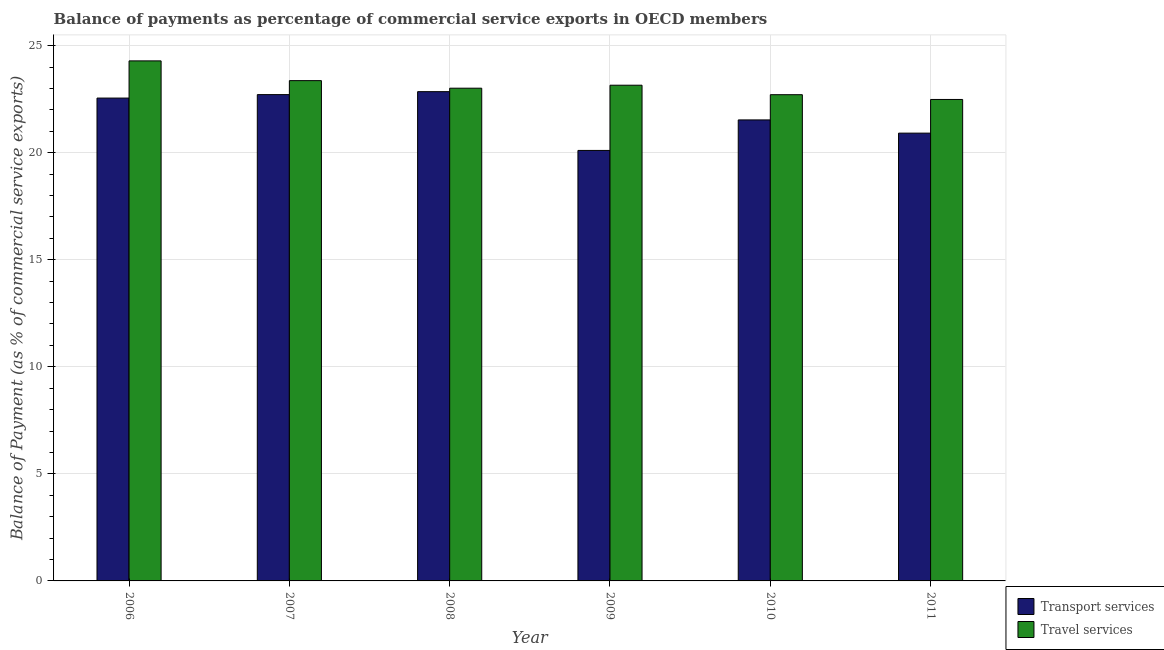How many groups of bars are there?
Offer a terse response. 6. Are the number of bars per tick equal to the number of legend labels?
Provide a succinct answer. Yes. How many bars are there on the 4th tick from the right?
Provide a short and direct response. 2. What is the balance of payments of transport services in 2007?
Give a very brief answer. 22.71. Across all years, what is the maximum balance of payments of travel services?
Make the answer very short. 24.29. Across all years, what is the minimum balance of payments of transport services?
Your answer should be very brief. 20.1. In which year was the balance of payments of transport services minimum?
Offer a terse response. 2009. What is the total balance of payments of travel services in the graph?
Provide a short and direct response. 139. What is the difference between the balance of payments of transport services in 2010 and that in 2011?
Keep it short and to the point. 0.62. What is the difference between the balance of payments of transport services in 2008 and the balance of payments of travel services in 2009?
Keep it short and to the point. 2.75. What is the average balance of payments of transport services per year?
Your response must be concise. 21.78. In the year 2011, what is the difference between the balance of payments of travel services and balance of payments of transport services?
Ensure brevity in your answer.  0. What is the ratio of the balance of payments of travel services in 2008 to that in 2010?
Make the answer very short. 1.01. Is the balance of payments of travel services in 2008 less than that in 2011?
Offer a very short reply. No. What is the difference between the highest and the second highest balance of payments of transport services?
Offer a very short reply. 0.14. What is the difference between the highest and the lowest balance of payments of transport services?
Provide a short and direct response. 2.75. What does the 1st bar from the left in 2010 represents?
Your response must be concise. Transport services. What does the 1st bar from the right in 2010 represents?
Your answer should be very brief. Travel services. How many bars are there?
Offer a very short reply. 12. Are all the bars in the graph horizontal?
Your answer should be very brief. No. How many years are there in the graph?
Your answer should be compact. 6. What is the difference between two consecutive major ticks on the Y-axis?
Your answer should be compact. 5. Where does the legend appear in the graph?
Your answer should be very brief. Bottom right. How are the legend labels stacked?
Your response must be concise. Vertical. What is the title of the graph?
Offer a terse response. Balance of payments as percentage of commercial service exports in OECD members. Does "Lower secondary rate" appear as one of the legend labels in the graph?
Provide a succinct answer. No. What is the label or title of the X-axis?
Your answer should be compact. Year. What is the label or title of the Y-axis?
Your answer should be compact. Balance of Payment (as % of commercial service exports). What is the Balance of Payment (as % of commercial service exports) of Transport services in 2006?
Provide a succinct answer. 22.55. What is the Balance of Payment (as % of commercial service exports) of Travel services in 2006?
Ensure brevity in your answer.  24.29. What is the Balance of Payment (as % of commercial service exports) in Transport services in 2007?
Keep it short and to the point. 22.71. What is the Balance of Payment (as % of commercial service exports) in Travel services in 2007?
Ensure brevity in your answer.  23.36. What is the Balance of Payment (as % of commercial service exports) in Transport services in 2008?
Ensure brevity in your answer.  22.85. What is the Balance of Payment (as % of commercial service exports) in Travel services in 2008?
Give a very brief answer. 23.01. What is the Balance of Payment (as % of commercial service exports) of Transport services in 2009?
Keep it short and to the point. 20.1. What is the Balance of Payment (as % of commercial service exports) in Travel services in 2009?
Offer a very short reply. 23.15. What is the Balance of Payment (as % of commercial service exports) of Transport services in 2010?
Give a very brief answer. 21.53. What is the Balance of Payment (as % of commercial service exports) in Travel services in 2010?
Ensure brevity in your answer.  22.71. What is the Balance of Payment (as % of commercial service exports) of Transport services in 2011?
Your response must be concise. 20.91. What is the Balance of Payment (as % of commercial service exports) of Travel services in 2011?
Ensure brevity in your answer.  22.48. Across all years, what is the maximum Balance of Payment (as % of commercial service exports) in Transport services?
Keep it short and to the point. 22.85. Across all years, what is the maximum Balance of Payment (as % of commercial service exports) in Travel services?
Give a very brief answer. 24.29. Across all years, what is the minimum Balance of Payment (as % of commercial service exports) in Transport services?
Your response must be concise. 20.1. Across all years, what is the minimum Balance of Payment (as % of commercial service exports) in Travel services?
Offer a terse response. 22.48. What is the total Balance of Payment (as % of commercial service exports) in Transport services in the graph?
Offer a terse response. 130.66. What is the total Balance of Payment (as % of commercial service exports) of Travel services in the graph?
Keep it short and to the point. 139. What is the difference between the Balance of Payment (as % of commercial service exports) of Transport services in 2006 and that in 2007?
Give a very brief answer. -0.16. What is the difference between the Balance of Payment (as % of commercial service exports) of Travel services in 2006 and that in 2007?
Make the answer very short. 0.92. What is the difference between the Balance of Payment (as % of commercial service exports) in Transport services in 2006 and that in 2008?
Offer a very short reply. -0.3. What is the difference between the Balance of Payment (as % of commercial service exports) in Travel services in 2006 and that in 2008?
Your response must be concise. 1.28. What is the difference between the Balance of Payment (as % of commercial service exports) of Transport services in 2006 and that in 2009?
Provide a short and direct response. 2.45. What is the difference between the Balance of Payment (as % of commercial service exports) in Travel services in 2006 and that in 2009?
Provide a succinct answer. 1.14. What is the difference between the Balance of Payment (as % of commercial service exports) of Transport services in 2006 and that in 2010?
Make the answer very short. 1.02. What is the difference between the Balance of Payment (as % of commercial service exports) of Travel services in 2006 and that in 2010?
Ensure brevity in your answer.  1.58. What is the difference between the Balance of Payment (as % of commercial service exports) of Transport services in 2006 and that in 2011?
Offer a very short reply. 1.64. What is the difference between the Balance of Payment (as % of commercial service exports) in Travel services in 2006 and that in 2011?
Provide a short and direct response. 1.8. What is the difference between the Balance of Payment (as % of commercial service exports) in Transport services in 2007 and that in 2008?
Your answer should be very brief. -0.14. What is the difference between the Balance of Payment (as % of commercial service exports) in Travel services in 2007 and that in 2008?
Ensure brevity in your answer.  0.35. What is the difference between the Balance of Payment (as % of commercial service exports) of Transport services in 2007 and that in 2009?
Keep it short and to the point. 2.61. What is the difference between the Balance of Payment (as % of commercial service exports) in Travel services in 2007 and that in 2009?
Offer a terse response. 0.21. What is the difference between the Balance of Payment (as % of commercial service exports) of Transport services in 2007 and that in 2010?
Give a very brief answer. 1.18. What is the difference between the Balance of Payment (as % of commercial service exports) in Travel services in 2007 and that in 2010?
Your response must be concise. 0.66. What is the difference between the Balance of Payment (as % of commercial service exports) of Transport services in 2007 and that in 2011?
Offer a terse response. 1.8. What is the difference between the Balance of Payment (as % of commercial service exports) of Travel services in 2007 and that in 2011?
Offer a very short reply. 0.88. What is the difference between the Balance of Payment (as % of commercial service exports) of Transport services in 2008 and that in 2009?
Give a very brief answer. 2.75. What is the difference between the Balance of Payment (as % of commercial service exports) of Travel services in 2008 and that in 2009?
Provide a succinct answer. -0.14. What is the difference between the Balance of Payment (as % of commercial service exports) of Transport services in 2008 and that in 2010?
Ensure brevity in your answer.  1.32. What is the difference between the Balance of Payment (as % of commercial service exports) in Travel services in 2008 and that in 2010?
Offer a terse response. 0.3. What is the difference between the Balance of Payment (as % of commercial service exports) in Transport services in 2008 and that in 2011?
Your answer should be very brief. 1.94. What is the difference between the Balance of Payment (as % of commercial service exports) in Travel services in 2008 and that in 2011?
Provide a succinct answer. 0.53. What is the difference between the Balance of Payment (as % of commercial service exports) in Transport services in 2009 and that in 2010?
Ensure brevity in your answer.  -1.43. What is the difference between the Balance of Payment (as % of commercial service exports) in Travel services in 2009 and that in 2010?
Your response must be concise. 0.44. What is the difference between the Balance of Payment (as % of commercial service exports) of Transport services in 2009 and that in 2011?
Keep it short and to the point. -0.81. What is the difference between the Balance of Payment (as % of commercial service exports) in Travel services in 2009 and that in 2011?
Give a very brief answer. 0.67. What is the difference between the Balance of Payment (as % of commercial service exports) in Transport services in 2010 and that in 2011?
Provide a succinct answer. 0.62. What is the difference between the Balance of Payment (as % of commercial service exports) of Travel services in 2010 and that in 2011?
Your response must be concise. 0.22. What is the difference between the Balance of Payment (as % of commercial service exports) in Transport services in 2006 and the Balance of Payment (as % of commercial service exports) in Travel services in 2007?
Keep it short and to the point. -0.81. What is the difference between the Balance of Payment (as % of commercial service exports) of Transport services in 2006 and the Balance of Payment (as % of commercial service exports) of Travel services in 2008?
Your answer should be very brief. -0.46. What is the difference between the Balance of Payment (as % of commercial service exports) of Transport services in 2006 and the Balance of Payment (as % of commercial service exports) of Travel services in 2009?
Provide a succinct answer. -0.6. What is the difference between the Balance of Payment (as % of commercial service exports) in Transport services in 2006 and the Balance of Payment (as % of commercial service exports) in Travel services in 2010?
Give a very brief answer. -0.16. What is the difference between the Balance of Payment (as % of commercial service exports) of Transport services in 2006 and the Balance of Payment (as % of commercial service exports) of Travel services in 2011?
Your answer should be very brief. 0.06. What is the difference between the Balance of Payment (as % of commercial service exports) in Transport services in 2007 and the Balance of Payment (as % of commercial service exports) in Travel services in 2008?
Offer a terse response. -0.3. What is the difference between the Balance of Payment (as % of commercial service exports) in Transport services in 2007 and the Balance of Payment (as % of commercial service exports) in Travel services in 2009?
Provide a succinct answer. -0.44. What is the difference between the Balance of Payment (as % of commercial service exports) of Transport services in 2007 and the Balance of Payment (as % of commercial service exports) of Travel services in 2010?
Ensure brevity in your answer.  0. What is the difference between the Balance of Payment (as % of commercial service exports) in Transport services in 2007 and the Balance of Payment (as % of commercial service exports) in Travel services in 2011?
Keep it short and to the point. 0.23. What is the difference between the Balance of Payment (as % of commercial service exports) of Transport services in 2008 and the Balance of Payment (as % of commercial service exports) of Travel services in 2009?
Make the answer very short. -0.3. What is the difference between the Balance of Payment (as % of commercial service exports) in Transport services in 2008 and the Balance of Payment (as % of commercial service exports) in Travel services in 2010?
Make the answer very short. 0.14. What is the difference between the Balance of Payment (as % of commercial service exports) in Transport services in 2008 and the Balance of Payment (as % of commercial service exports) in Travel services in 2011?
Give a very brief answer. 0.37. What is the difference between the Balance of Payment (as % of commercial service exports) in Transport services in 2009 and the Balance of Payment (as % of commercial service exports) in Travel services in 2010?
Give a very brief answer. -2.6. What is the difference between the Balance of Payment (as % of commercial service exports) in Transport services in 2009 and the Balance of Payment (as % of commercial service exports) in Travel services in 2011?
Make the answer very short. -2.38. What is the difference between the Balance of Payment (as % of commercial service exports) in Transport services in 2010 and the Balance of Payment (as % of commercial service exports) in Travel services in 2011?
Offer a very short reply. -0.96. What is the average Balance of Payment (as % of commercial service exports) of Transport services per year?
Ensure brevity in your answer.  21.78. What is the average Balance of Payment (as % of commercial service exports) of Travel services per year?
Ensure brevity in your answer.  23.17. In the year 2006, what is the difference between the Balance of Payment (as % of commercial service exports) in Transport services and Balance of Payment (as % of commercial service exports) in Travel services?
Keep it short and to the point. -1.74. In the year 2007, what is the difference between the Balance of Payment (as % of commercial service exports) in Transport services and Balance of Payment (as % of commercial service exports) in Travel services?
Offer a very short reply. -0.65. In the year 2008, what is the difference between the Balance of Payment (as % of commercial service exports) of Transport services and Balance of Payment (as % of commercial service exports) of Travel services?
Give a very brief answer. -0.16. In the year 2009, what is the difference between the Balance of Payment (as % of commercial service exports) of Transport services and Balance of Payment (as % of commercial service exports) of Travel services?
Make the answer very short. -3.05. In the year 2010, what is the difference between the Balance of Payment (as % of commercial service exports) of Transport services and Balance of Payment (as % of commercial service exports) of Travel services?
Your response must be concise. -1.18. In the year 2011, what is the difference between the Balance of Payment (as % of commercial service exports) in Transport services and Balance of Payment (as % of commercial service exports) in Travel services?
Make the answer very short. -1.57. What is the ratio of the Balance of Payment (as % of commercial service exports) of Travel services in 2006 to that in 2007?
Provide a succinct answer. 1.04. What is the ratio of the Balance of Payment (as % of commercial service exports) in Transport services in 2006 to that in 2008?
Your answer should be compact. 0.99. What is the ratio of the Balance of Payment (as % of commercial service exports) of Travel services in 2006 to that in 2008?
Provide a short and direct response. 1.06. What is the ratio of the Balance of Payment (as % of commercial service exports) in Transport services in 2006 to that in 2009?
Keep it short and to the point. 1.12. What is the ratio of the Balance of Payment (as % of commercial service exports) of Travel services in 2006 to that in 2009?
Your response must be concise. 1.05. What is the ratio of the Balance of Payment (as % of commercial service exports) of Transport services in 2006 to that in 2010?
Ensure brevity in your answer.  1.05. What is the ratio of the Balance of Payment (as % of commercial service exports) of Travel services in 2006 to that in 2010?
Your answer should be very brief. 1.07. What is the ratio of the Balance of Payment (as % of commercial service exports) in Transport services in 2006 to that in 2011?
Give a very brief answer. 1.08. What is the ratio of the Balance of Payment (as % of commercial service exports) of Travel services in 2006 to that in 2011?
Give a very brief answer. 1.08. What is the ratio of the Balance of Payment (as % of commercial service exports) in Transport services in 2007 to that in 2008?
Ensure brevity in your answer.  0.99. What is the ratio of the Balance of Payment (as % of commercial service exports) of Travel services in 2007 to that in 2008?
Provide a short and direct response. 1.02. What is the ratio of the Balance of Payment (as % of commercial service exports) of Transport services in 2007 to that in 2009?
Your response must be concise. 1.13. What is the ratio of the Balance of Payment (as % of commercial service exports) of Travel services in 2007 to that in 2009?
Give a very brief answer. 1.01. What is the ratio of the Balance of Payment (as % of commercial service exports) of Transport services in 2007 to that in 2010?
Your answer should be compact. 1.05. What is the ratio of the Balance of Payment (as % of commercial service exports) of Travel services in 2007 to that in 2010?
Offer a very short reply. 1.03. What is the ratio of the Balance of Payment (as % of commercial service exports) in Transport services in 2007 to that in 2011?
Ensure brevity in your answer.  1.09. What is the ratio of the Balance of Payment (as % of commercial service exports) in Travel services in 2007 to that in 2011?
Give a very brief answer. 1.04. What is the ratio of the Balance of Payment (as % of commercial service exports) of Transport services in 2008 to that in 2009?
Provide a succinct answer. 1.14. What is the ratio of the Balance of Payment (as % of commercial service exports) of Transport services in 2008 to that in 2010?
Your answer should be compact. 1.06. What is the ratio of the Balance of Payment (as % of commercial service exports) of Travel services in 2008 to that in 2010?
Provide a short and direct response. 1.01. What is the ratio of the Balance of Payment (as % of commercial service exports) in Transport services in 2008 to that in 2011?
Your response must be concise. 1.09. What is the ratio of the Balance of Payment (as % of commercial service exports) of Travel services in 2008 to that in 2011?
Keep it short and to the point. 1.02. What is the ratio of the Balance of Payment (as % of commercial service exports) of Transport services in 2009 to that in 2010?
Your response must be concise. 0.93. What is the ratio of the Balance of Payment (as % of commercial service exports) in Travel services in 2009 to that in 2010?
Your answer should be compact. 1.02. What is the ratio of the Balance of Payment (as % of commercial service exports) of Transport services in 2009 to that in 2011?
Offer a very short reply. 0.96. What is the ratio of the Balance of Payment (as % of commercial service exports) in Travel services in 2009 to that in 2011?
Your response must be concise. 1.03. What is the ratio of the Balance of Payment (as % of commercial service exports) in Transport services in 2010 to that in 2011?
Ensure brevity in your answer.  1.03. What is the ratio of the Balance of Payment (as % of commercial service exports) of Travel services in 2010 to that in 2011?
Offer a terse response. 1.01. What is the difference between the highest and the second highest Balance of Payment (as % of commercial service exports) of Transport services?
Provide a short and direct response. 0.14. What is the difference between the highest and the second highest Balance of Payment (as % of commercial service exports) of Travel services?
Make the answer very short. 0.92. What is the difference between the highest and the lowest Balance of Payment (as % of commercial service exports) of Transport services?
Provide a short and direct response. 2.75. What is the difference between the highest and the lowest Balance of Payment (as % of commercial service exports) of Travel services?
Your answer should be very brief. 1.8. 